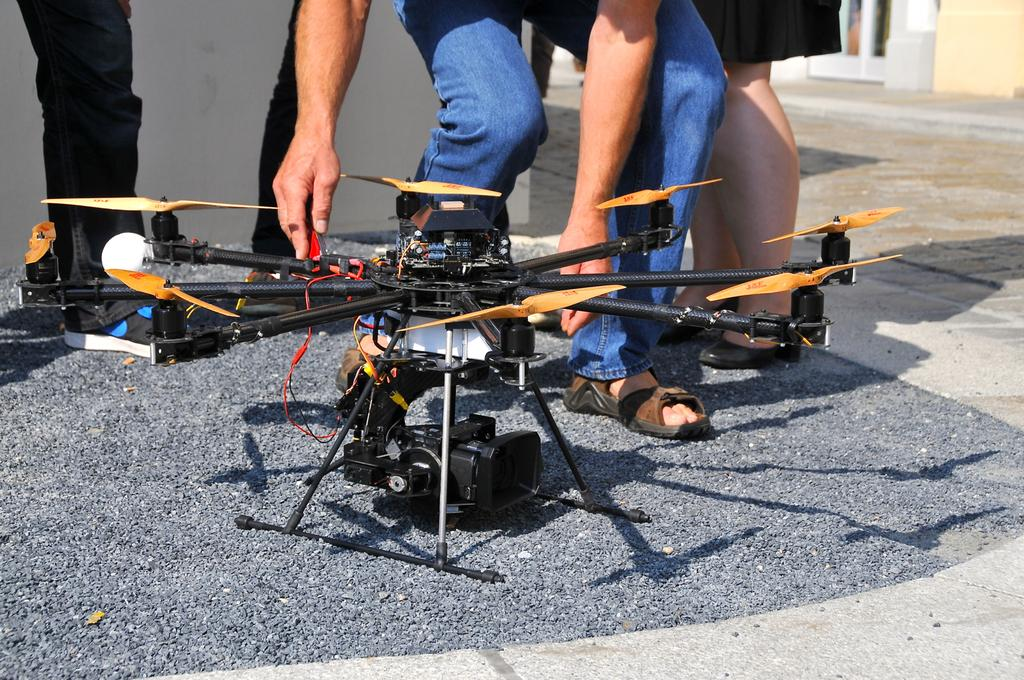What can be seen in the image? There are persons' legs and a drone in the image. Can you describe the drone in the image? The drone is located in the middle of the image. What type of agreement is being discussed by the persons in the image? There is no indication of a discussion or agreement in the image, as it only shows persons' legs and a drone. Can you tell me how many basketballs are visible in the image? There are no basketballs present in the image. 